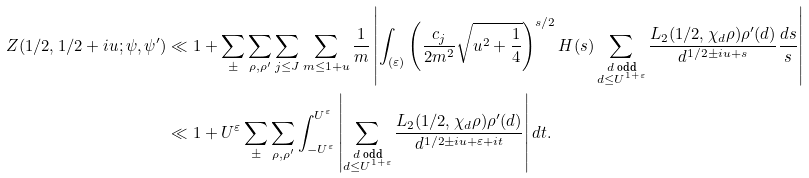<formula> <loc_0><loc_0><loc_500><loc_500>Z ( 1 / 2 , 1 / 2 + i u ; \psi , \psi ^ { \prime } ) & \ll 1 + \sum _ { \pm } \sum _ { \rho , \rho ^ { \prime } } \sum _ { j \leq J } \sum _ { m \leq 1 + u } \frac { 1 } { m } \left | \int _ { ( \varepsilon ) } \left ( \frac { c _ { j } } { 2 m ^ { 2 } } \sqrt { u ^ { 2 } + \frac { 1 } { 4 } } \right ) ^ { s / 2 } H ( s ) \sum _ { \substack { d \text { odd} \\ d \leq U ^ { 1 + \varepsilon } } } \frac { L _ { 2 } ( 1 / 2 , \chi _ { d } \rho ) \rho ^ { \prime } ( d ) } { d ^ { 1 / 2 \pm i u + s } } \frac { d s } { s } \right | \\ & \ll 1 + U ^ { \varepsilon } \sum _ { \pm } \sum _ { \rho , \rho ^ { \prime } } \int _ { - U ^ { \varepsilon } } ^ { U ^ { \varepsilon } } \left | \sum _ { \substack { d \text { odd} \\ d \leq U ^ { 1 + \varepsilon } } } \frac { L _ { 2 } ( 1 / 2 , \chi _ { d } \rho ) \rho ^ { \prime } ( d ) } { d ^ { 1 / 2 \pm i u + \varepsilon + i t } } \right | d t .</formula> 